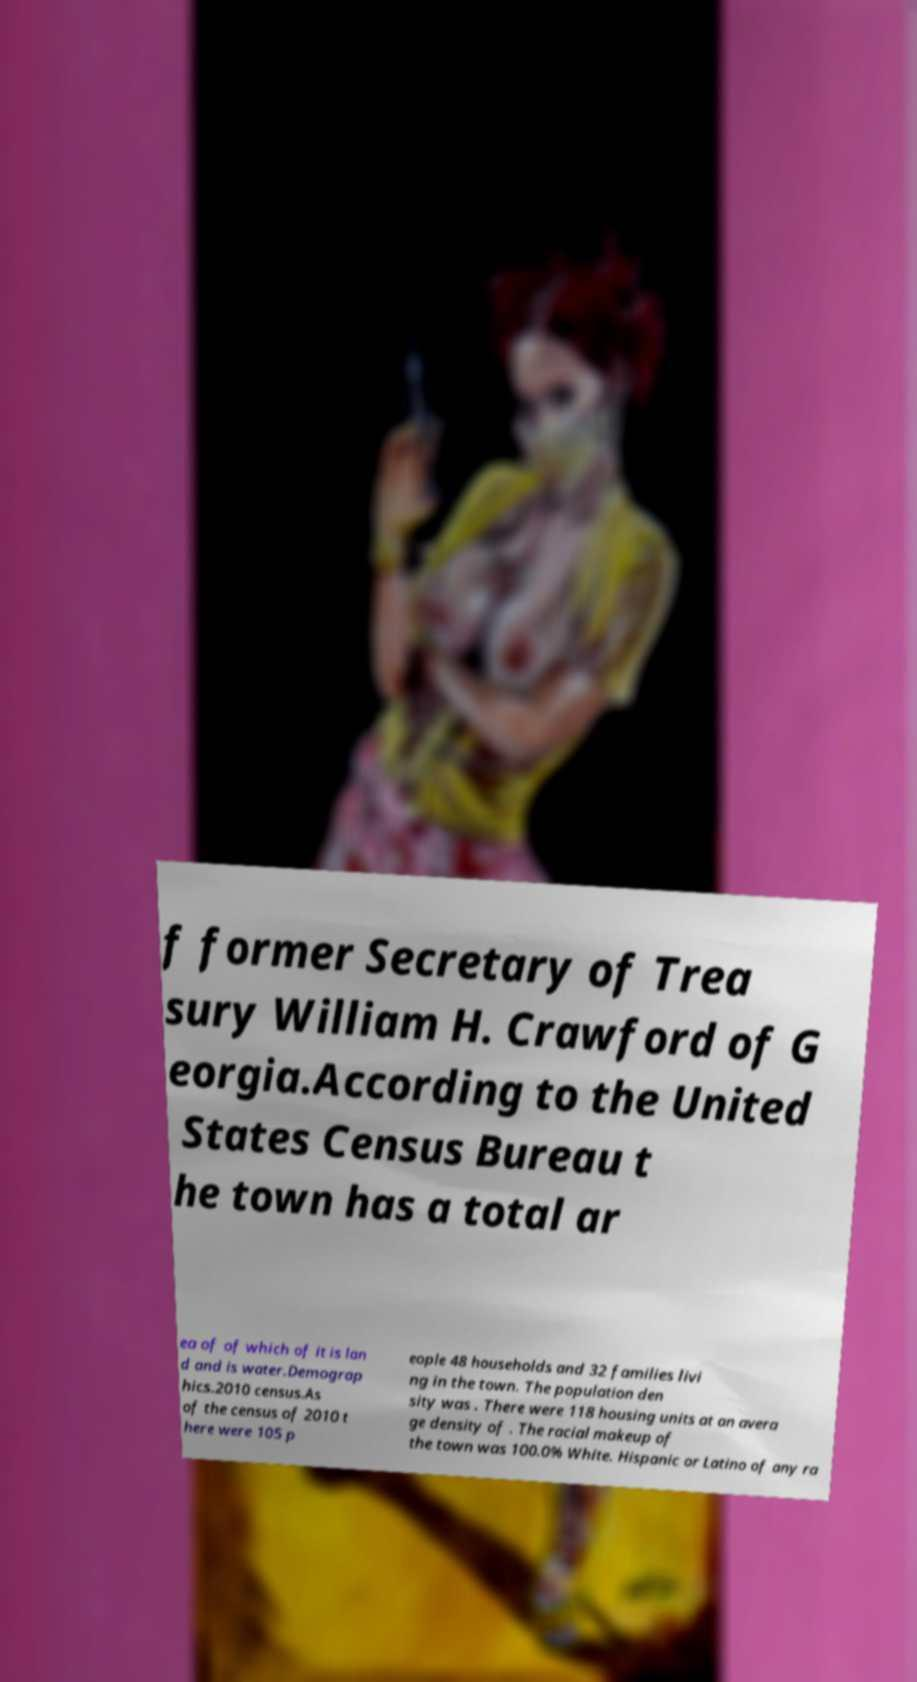Could you assist in decoding the text presented in this image and type it out clearly? f former Secretary of Trea sury William H. Crawford of G eorgia.According to the United States Census Bureau t he town has a total ar ea of of which of it is lan d and is water.Demograp hics.2010 census.As of the census of 2010 t here were 105 p eople 48 households and 32 families livi ng in the town. The population den sity was . There were 118 housing units at an avera ge density of . The racial makeup of the town was 100.0% White. Hispanic or Latino of any ra 